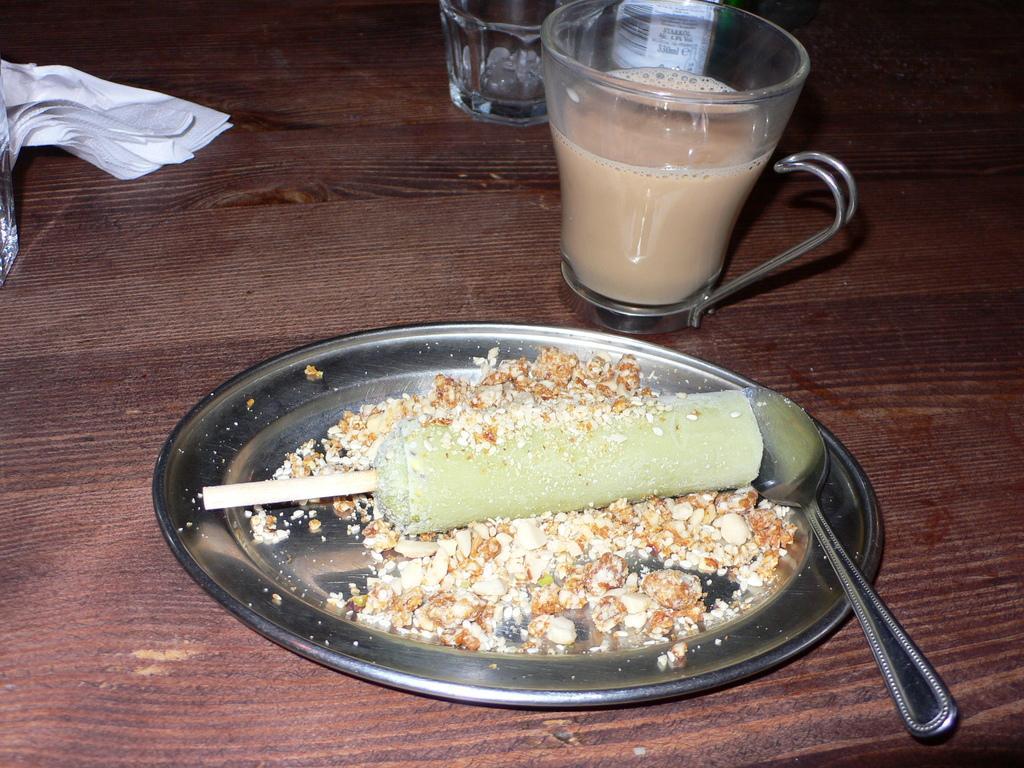In one or two sentences, can you explain what this image depicts? In this image we can see a plate with food items and spoon kept on it, a cup with a drink in it, glass, bottle with a label on it and a cloth are placed on the wooden table. 